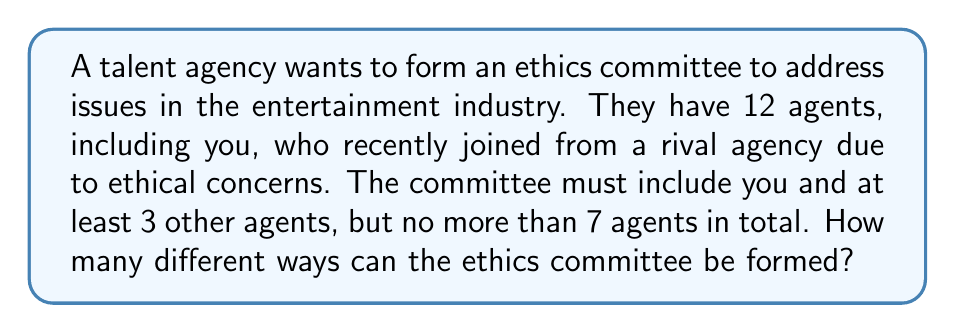What is the answer to this math problem? Let's approach this step-by-step:

1) You must be on the committee, so we only need to choose the other members.

2) The committee can have a minimum of 3 other agents (4 total) and a maximum of 6 other agents (7 total).

3) We need to sum up the number of ways to choose 3, 4, 5, or 6 agents from the remaining 11 agents.

4) This can be represented as a sum of combinations:

   $$\sum_{k=3}^6 \binom{11}{k}$$

5) Let's calculate each combination:

   For $k=3$: $\binom{11}{3} = \frac{11!}{3!(11-3)!} = 165$
   For $k=4$: $\binom{11}{4} = \frac{11!}{4!(11-4)!} = 330$
   For $k=5$: $\binom{11}{5} = \frac{11!}{5!(11-5)!} = 462$
   For $k=6$: $\binom{11}{6} = \frac{11!}{6!(11-6)!} = 462$

6) Sum these results:

   $165 + 330 + 462 + 462 = 1419$

Therefore, there are 1419 different ways to form the ethics committee.
Answer: 1419 